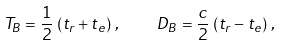Convert formula to latex. <formula><loc_0><loc_0><loc_500><loc_500>T _ { B } = \frac { 1 } { 2 } \, \left ( t _ { r } + t _ { e } \right ) \, , \quad D _ { B } = \frac { c } { 2 } \, \left ( t _ { r } - t _ { e } \right ) \, ,</formula> 